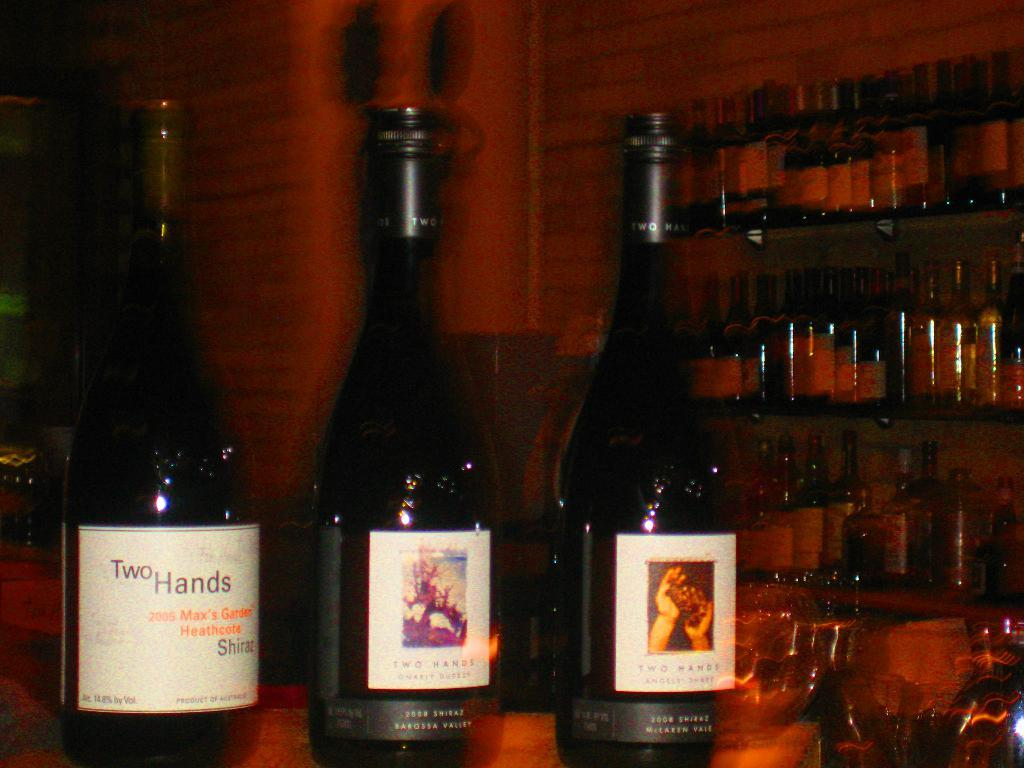What objects are on the table in the image? There are bottles on the table in the image. Are there any other locations where bottles can be found in the image? Yes, there are bottles on a shelf in the image. What can be seen in the background of the image? There is a wall in the background of the image. What type of flower is growing on the table in the image? There are no flowers present in the image; it features bottles on a table and a shelf, with a wall in the background. 